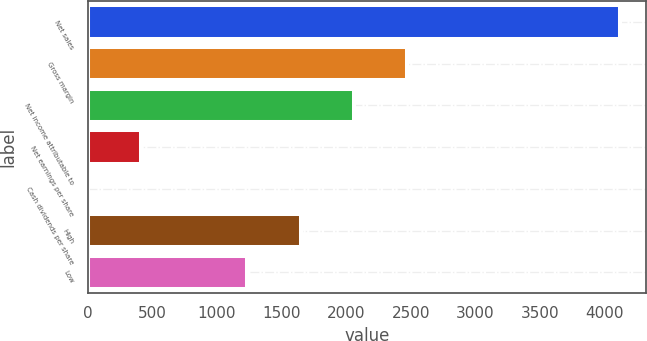Convert chart to OTSL. <chart><loc_0><loc_0><loc_500><loc_500><bar_chart><fcel>Net sales<fcel>Gross margin<fcel>Net income attributable to<fcel>Net earnings per share<fcel>Cash dividends per share<fcel>High<fcel>Low<nl><fcel>4118<fcel>2471<fcel>2059.25<fcel>412.25<fcel>0.5<fcel>1647.5<fcel>1235.75<nl></chart> 